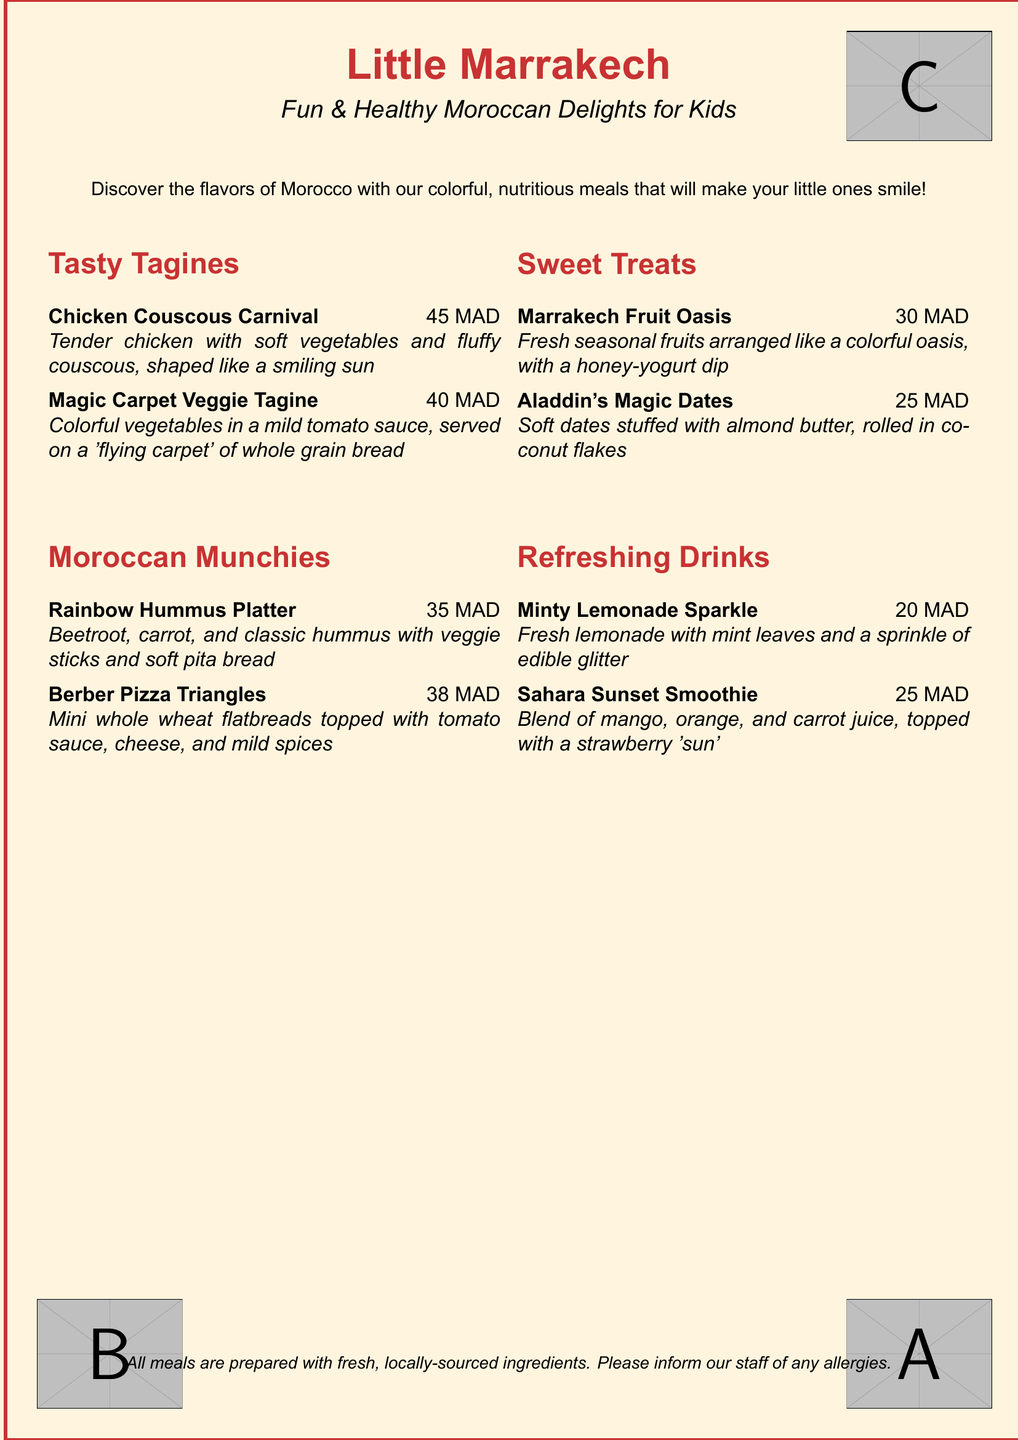What is the name of the kid's menu? The name of the kid's menu is "Little Marrakech."
Answer: Little Marrakech What is the price of the Chicken Couscous Carnival? The price for the Chicken Couscous Carnival is listed on the menu next to the item.
Answer: 45 MAD Which drink has edible glitter? The menu includes drinks with a unique feature, and the one with edible glitter is specifically mentioned.
Answer: Minty Lemonade Sparkle What are the ingredients in Aladdin's Magic Dates? The ingredients for the treat are stated clearly in the menu description, showing what is stuffed in the dates.
Answer: Almond butter, coconut flakes How many items are in the "Sweet Treats" section? The menu section contains a specific number of listed items, indicating choices available.
Answer: 2 items What type of bread is used in the Magic Carpet Veggie Tagine? The type of bread accompanying the meal is explicitly referenced in the menu item description.
Answer: Whole grain bread What item represents a colorful oasis on the menu? One of the sweet treats is arranged as a colorful oasis and is named directly.
Answer: Marrakech Fruit Oasis Which tagine is made from vegetables? The menu differentiates between types of tagines, and this one specifically highlights its main ingredient.
Answer: Magic Carpet Veggie Tagine 